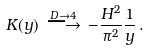Convert formula to latex. <formula><loc_0><loc_0><loc_500><loc_500>K ( y ) \, \stackrel { D \rightarrow 4 } { \longrightarrow } \, - \frac { H ^ { 2 } } { \pi ^ { 2 } } \frac { 1 } { y } \, .</formula> 